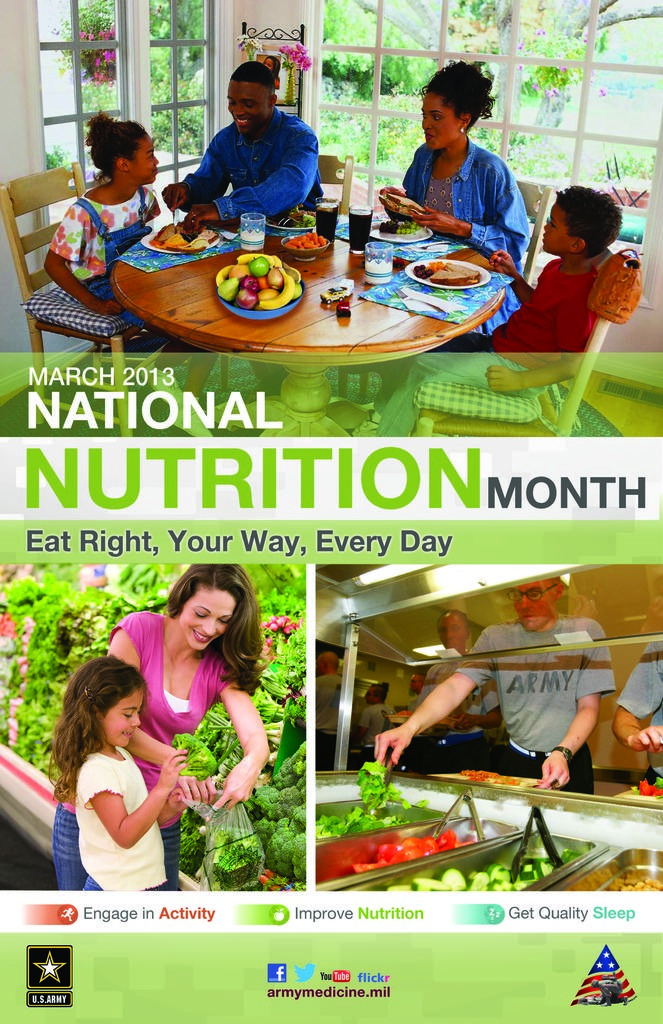What is the main theme or subject of the image? The image is a promotion picture about national nutrition. What aspect of nutrition might be emphasized in the image? The image could be promoting healthy eating habits, balanced diets, or nutritional guidelines. What type of game or play is depicted in the image? There is no game or play depicted in the image, as it is focused on promoting national nutrition. 